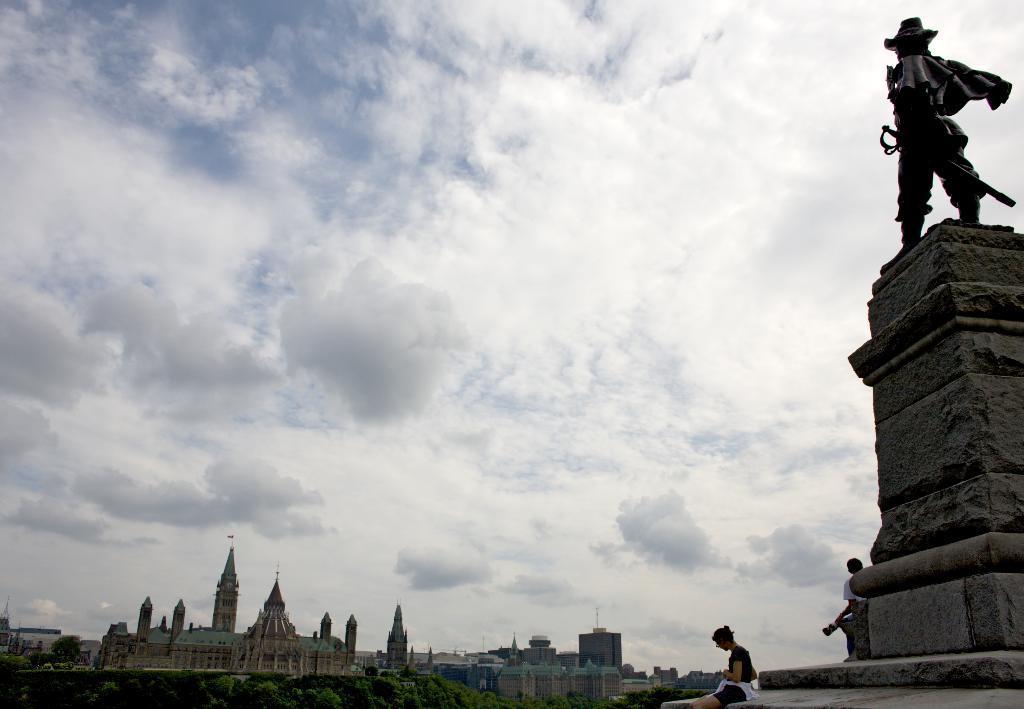How would you summarize this image in a sentence or two? in this image we can see a statue, pedestal, persons sitting and standing on the pedestal, buildings, flags, trees and sky with clouds in the background. 